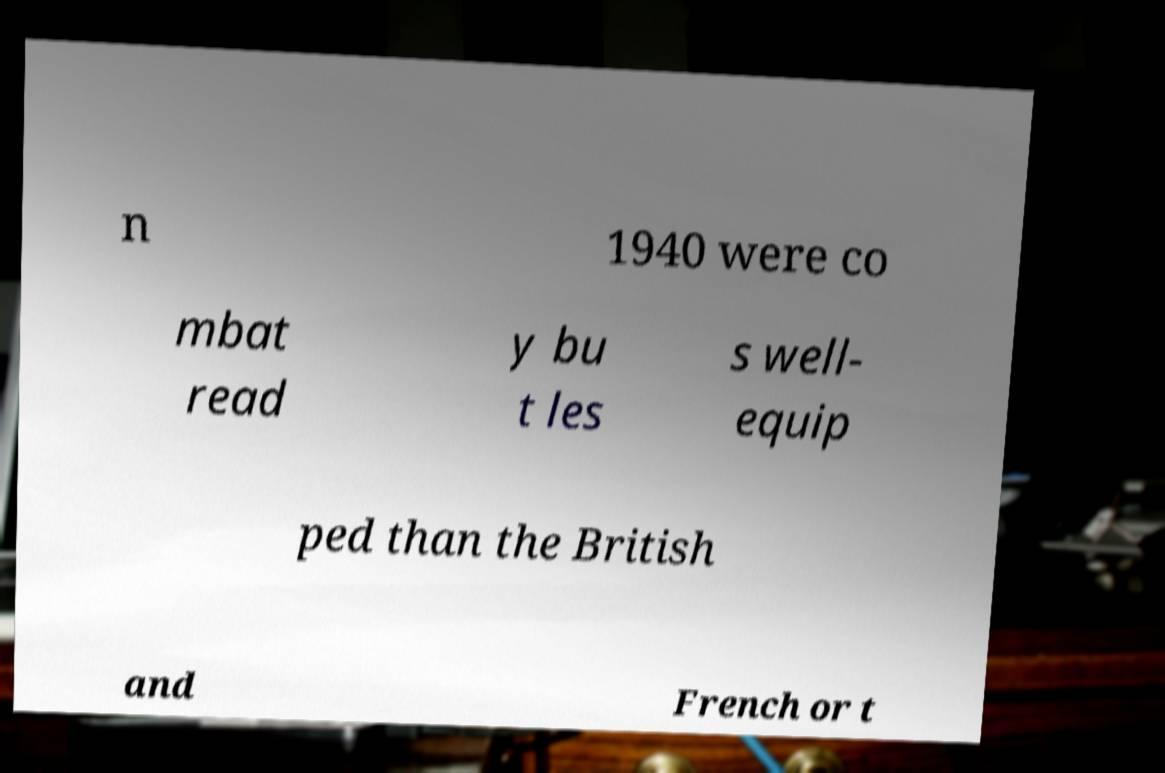There's text embedded in this image that I need extracted. Can you transcribe it verbatim? n 1940 were co mbat read y bu t les s well- equip ped than the British and French or t 